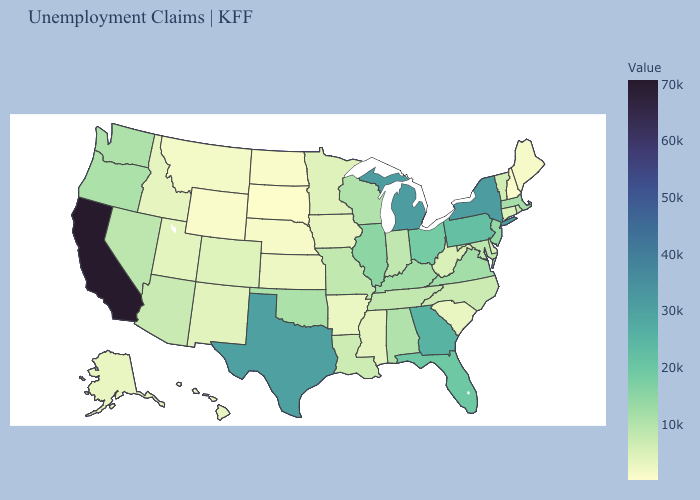Among the states that border Arkansas , does Louisiana have the highest value?
Be succinct. No. Does California have the highest value in the USA?
Short answer required. Yes. Does Colorado have the lowest value in the West?
Give a very brief answer. No. Does South Carolina have the lowest value in the USA?
Give a very brief answer. No. Among the states that border Tennessee , which have the lowest value?
Short answer required. Arkansas. Does Arkansas have the lowest value in the South?
Write a very short answer. Yes. Which states have the lowest value in the USA?
Be succinct. South Dakota. Is the legend a continuous bar?
Write a very short answer. Yes. 